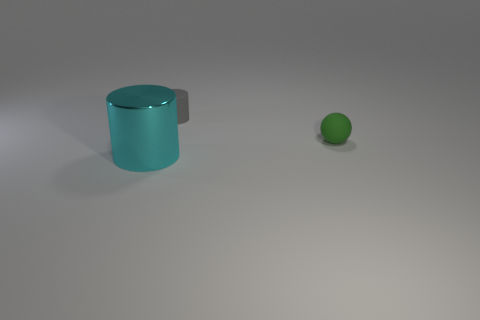Are there any other things that have the same size as the cyan thing?
Make the answer very short. No. Is the number of objects that are left of the green object greater than the number of tiny objects that are on the right side of the gray thing?
Provide a succinct answer. Yes. What size is the thing on the left side of the cylinder that is behind the cylinder that is in front of the tiny matte ball?
Provide a succinct answer. Large. Is the material of the green thing the same as the thing that is in front of the small green matte thing?
Your answer should be very brief. No. Does the cyan thing have the same shape as the tiny green thing?
Your response must be concise. No. How many other objects are the same material as the big cyan cylinder?
Make the answer very short. 0. How many tiny gray matte objects have the same shape as the big cyan metallic thing?
Offer a very short reply. 1. The object that is in front of the small gray matte thing and on the left side of the green thing is what color?
Your answer should be compact. Cyan. What number of red things are there?
Your answer should be compact. 0. Do the sphere and the gray rubber thing have the same size?
Your response must be concise. Yes. 